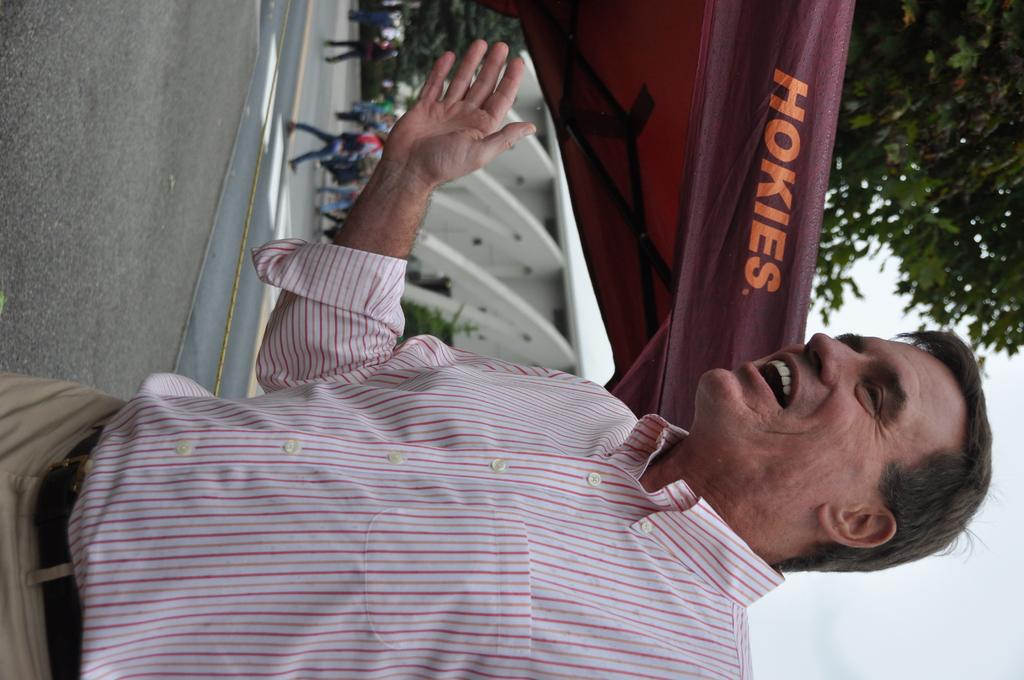Who is present in the image? There is a man in the image. What is happening in the background of the image? People are walking on the road, and there are trees, a building, a tent, and clouds in the sky in the background of the image. What type of books can be seen on fire in the image? There are no books or fire present in the image. 